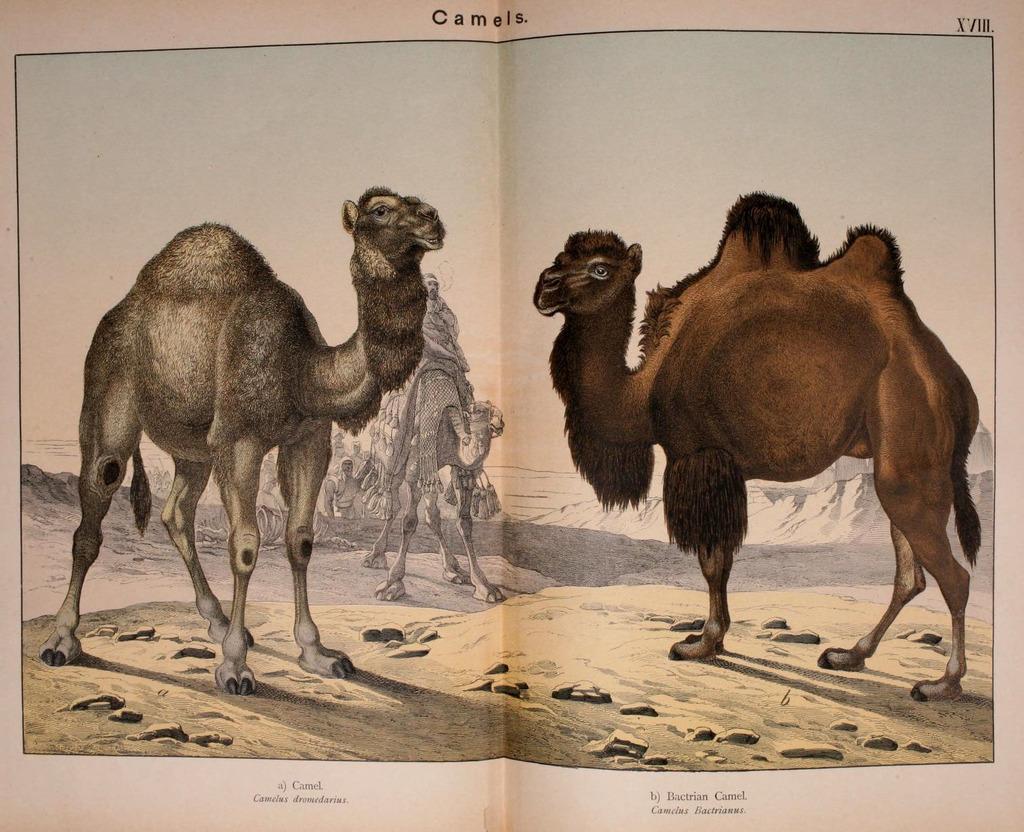In one or two sentences, can you explain what this image depicts? In this image there is a paper. On the paper there is a sketch of two camels, in between them there is a person sat on the other camel. At the top and bottom of the paper there is some text. 